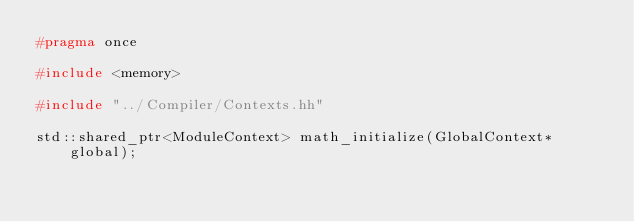Convert code to text. <code><loc_0><loc_0><loc_500><loc_500><_C++_>#pragma once

#include <memory>

#include "../Compiler/Contexts.hh"

std::shared_ptr<ModuleContext> math_initialize(GlobalContext* global);
</code> 